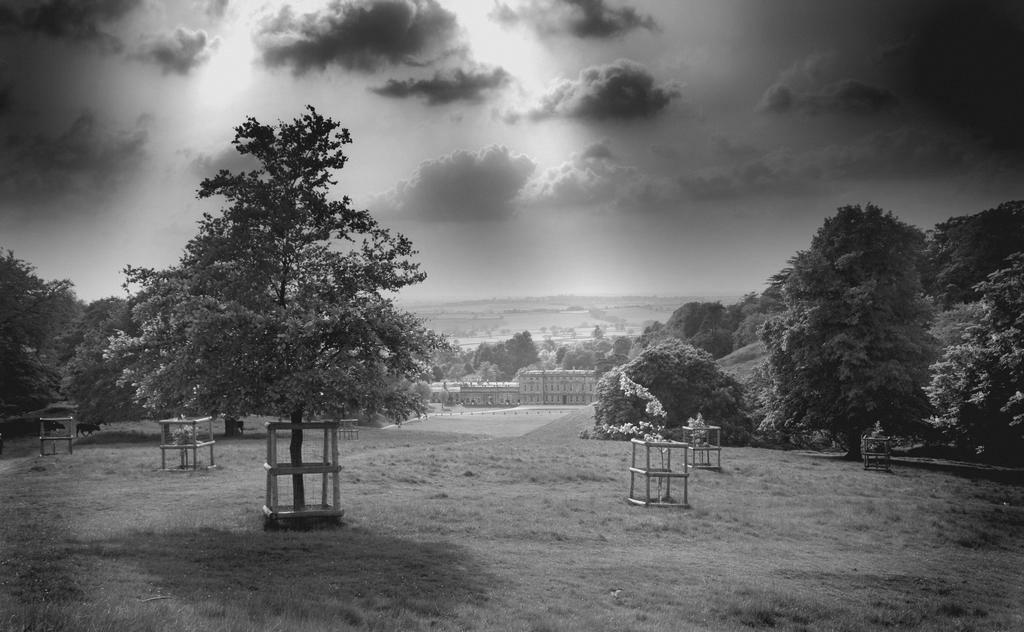What type of vegetation can be seen in the image? There are trees in the image. What is surrounding the plants and trees? There is a wooden fence around the plants and trees. What type of structures can be seen in the image? There are buildings visible in the image. How would you describe the sky in the image? The sky is cloudy in the image. What type of loaf is being used to build the wooden fence in the image? There is no loaf present in the image, and the wooden fence is not made of loaves. 